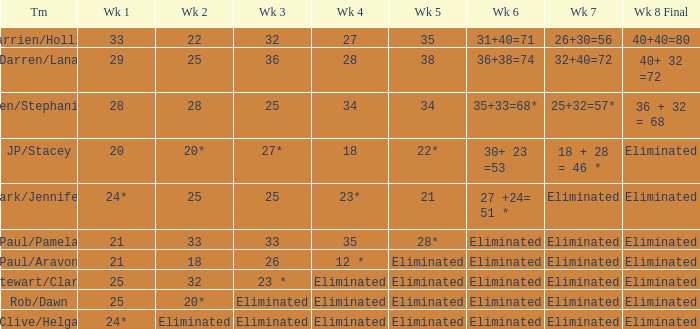Name the team for week 1 of 28 Ben/Stephanie. 